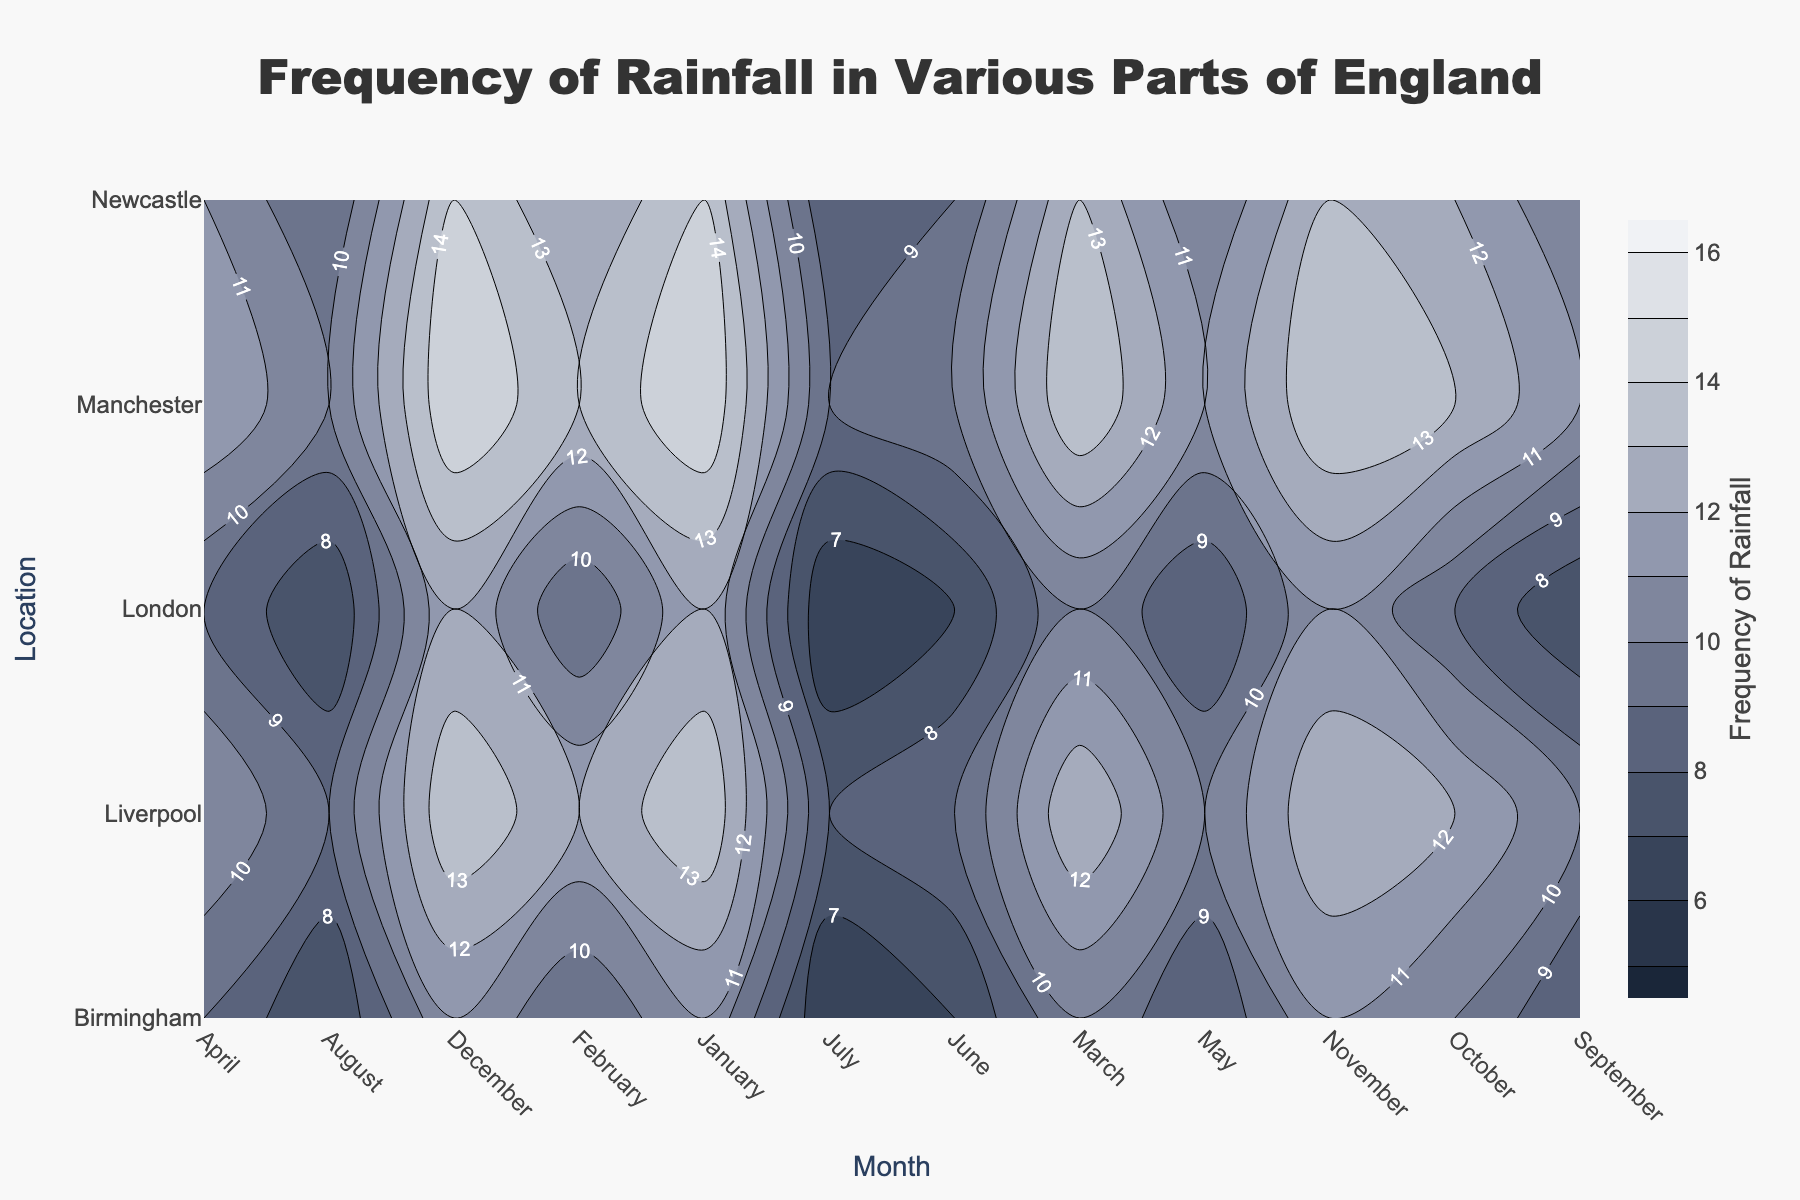What is the title of the plot? The title is located at the top of the plot and describes what the figure is about. It reads 'Frequency of Rainfall in Various Parts of England'.
Answer: Frequency of Rainfall in Various Parts of England Which month has the highest frequency of rainfall in Manchester? The contour plot allows us to compare the frequency of rainfall across different months for one location. For Manchester, the highest value in the y-axis occurs in January and December.
Answer: January and December In which locations does July have the lowest frequency of rainfall? By observing the contour lines or the color gradient for July along the x-axis, you can identify the locations on the y-axis where the frequency values are lowest. London and Birmingham have the lowest frequency in July.
Answer: London and Birmingham Compare the frequency of rainfall in Liverpool in October to that in February. Locate Liverpool on the y-axis and find the contour lines or color gradients corresponding to October and February along the x-axis. October shows 12, and February shows 12 as well.
Answer: Equal, 12 What's the average frequency of rainfall for Newcastle from January to March? Locate Newcastle on the y-axis, and identify the frequency values for January, February, and March (14, 12, 13). Then, find the average: (14 + 12 + 13) / 3 = 13.
Answer: 13 Is there a month where all locations experience the same frequency of rainfall? Check each month along the x-axis to see if the contours are aligned horizontally, indicating the same frequency for all locations. Notably, such a pattern does not exist.
Answer: No How does the frequency of rainfall in London change from June to November? Follow London on the y-axis and observe the change in frequency values from June (7) through November (11). The values increase as you move from June to November (7, 6, 7, 9, 11).
Answer: It increases In which month does Birmingham have its minimum frequency of rainfall? Find Birmingham on the y-axis and look for the minimum value among the months on the x-axis. The lowest frequency is found in July.
Answer: July What's the range of the frequency of rainfall in Liverpool over the entire year? Identify the highest and lowest frequency values for Liverpool on the y-axis from January to December. The highest is 14 (December) and the lowest is 8 (July). The range is 14 - 8 = 6.
Answer: 6 Which location experiences the most consistent frequency of rainfall throughout the year? "Consistent" implies little variation throughout the months. Compare the contour gradient for each location throughout the months. London shows the least variation (ranging slightly between 6 to 12).
Answer: London 